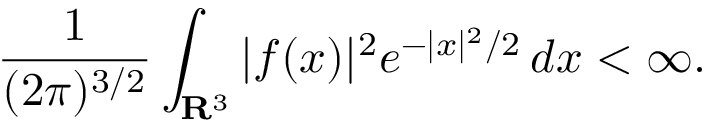Convert formula to latex. <formula><loc_0><loc_0><loc_500><loc_500>{ \frac { 1 } { ( 2 \pi ) ^ { 3 / 2 } } } \int _ { R ^ { 3 } } | f ( x ) | ^ { 2 } e ^ { - | x | ^ { 2 } / 2 } \, d x < \infty .</formula> 